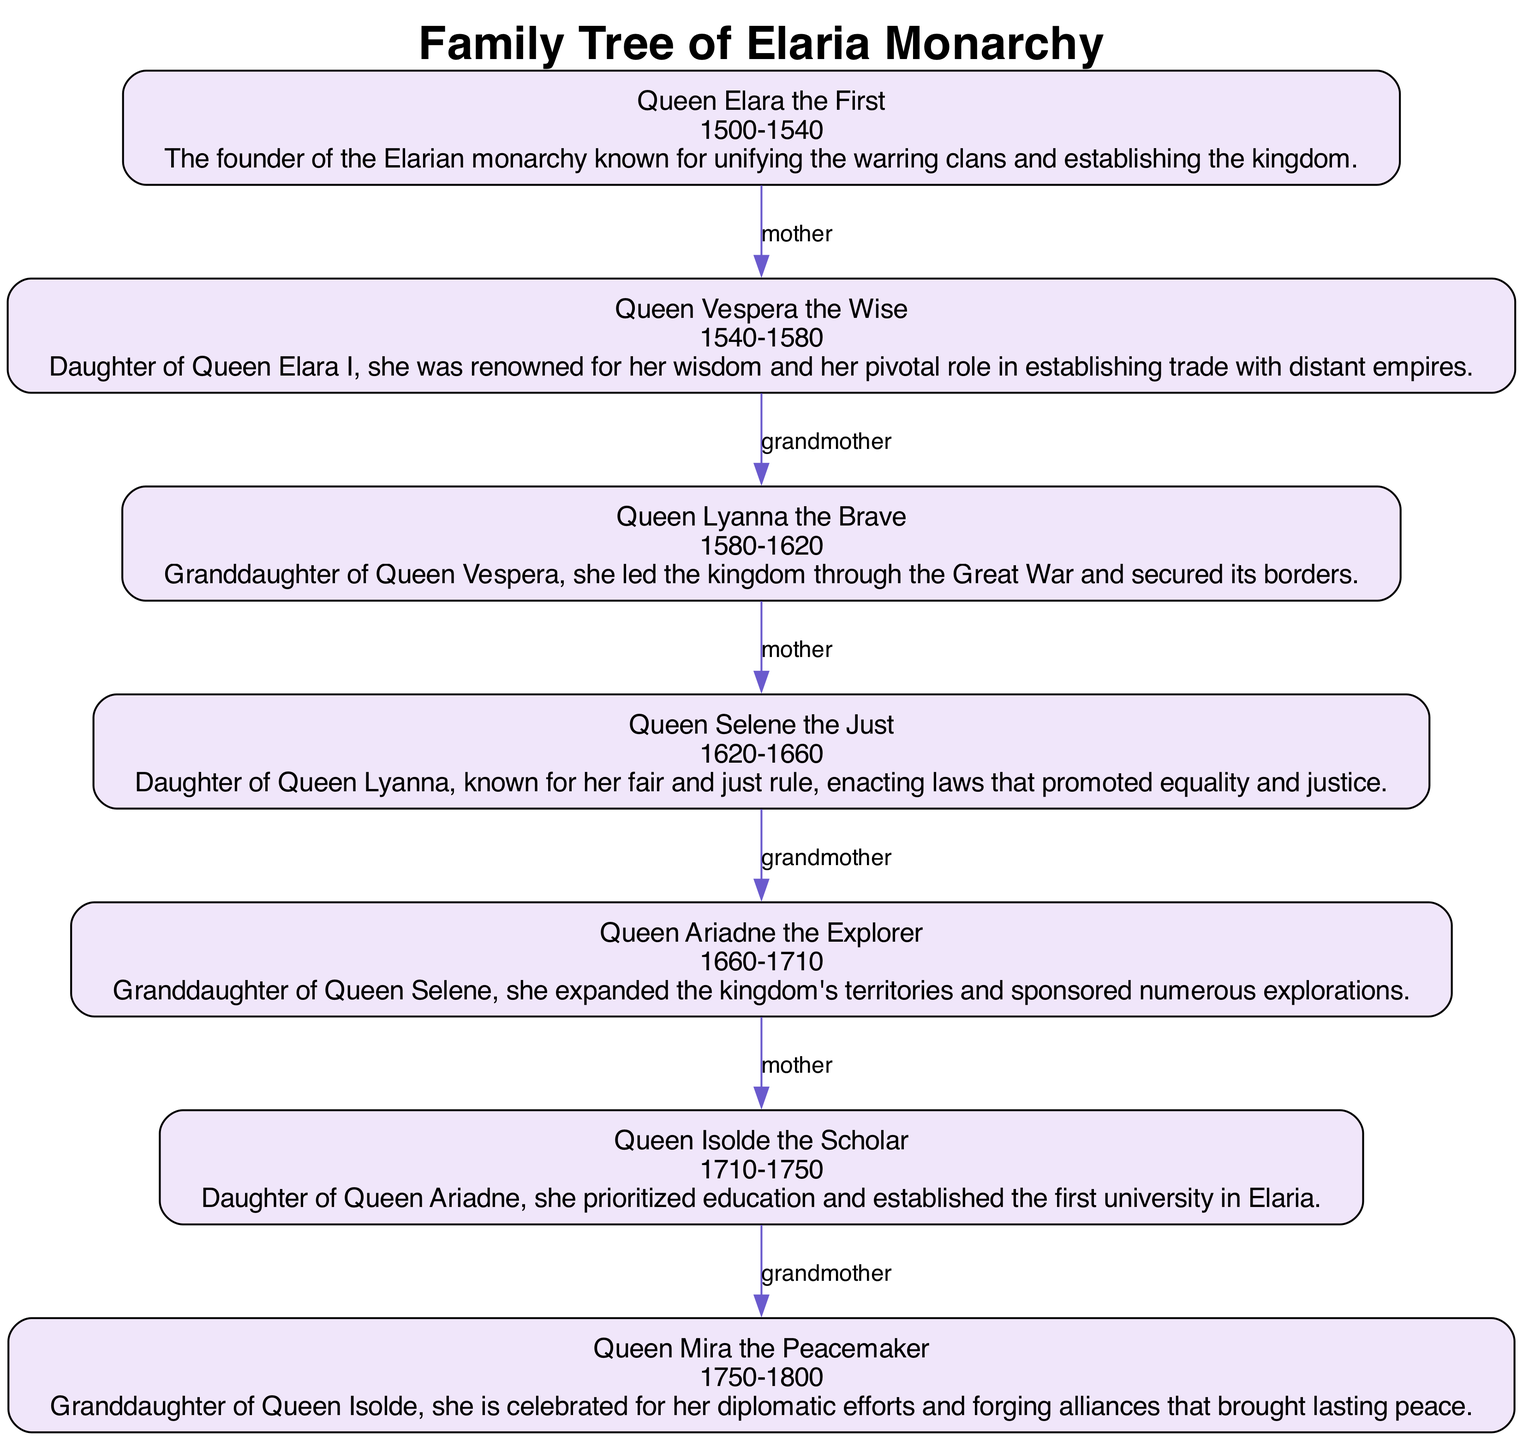What is the name of the first queen of Elaria? The diagram clearly shows the name of the first queen of Elaria at the top of the family tree, which is "Queen Elara the First."
Answer: Queen Elara the First How many queens ruled Elaria? There are seven nodes in the diagram representing the queens of Elaria, indicating the total number of queens who ruled the kingdom.
Answer: 7 Who was Queen Vespera's mother? The diagram indicates a direct connection labeled "mother" from "Queen Elara the First" to "Queen Vespera the Wise," showing their relationship clearly.
Answer: Queen Elara the First What relation does Queen Selene have to Queen Ariadne? The diagram illustrates a connection labeled "grandmother" from "Queen Selene the Just" to "Queen Ariadne the Explorer," indicating that Queen Selene is the grandmother of Queen Ariadne.
Answer: Grandmother Which queen is recognized for establishing the first university in Elaria? The description associated with "Queen Isolde the Scholar" within the diagram explicitly states that she prioritized education and established the first university in Elaria.
Answer: Queen Isolde the Scholar Which queen ruled between 1580 and 1620? The reign time period for each queen is indicated in the diagram, and "Queen Lyanna the Brave" is described as having ruled during the specified years.
Answer: Queen Lyanna the Brave How is Queen Mira related to Queen Vespera? The diagram shows a connection between "Queen Vespera the Wise" and her granddaughter, "Queen Lyanna the Brave," indicating that Queen Mira is two generations removed from Queen Vespera, making her a great-granddaughter.
Answer: Great-granddaughter What significant act was Queen Ariadne known for? The description associated with "Queen Ariadne the Explorer" highlights her accomplishments in expanding the kingdom's territories and sponsoring explorations, which provide insight into her significant acts.
Answer: Expanding territories Which queen's rule was characterized by promoting equality and justice? The diagram contains a description under "Queen Selene the Just" mentioning her fair and just rule, focusing on enacting laws that promoted equality and justice.
Answer: Queen Selene the Just 